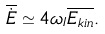Convert formula to latex. <formula><loc_0><loc_0><loc_500><loc_500>\overline { \dot { E } } \simeq 4 \omega _ { I } \overline { E _ { k i n } } .</formula> 